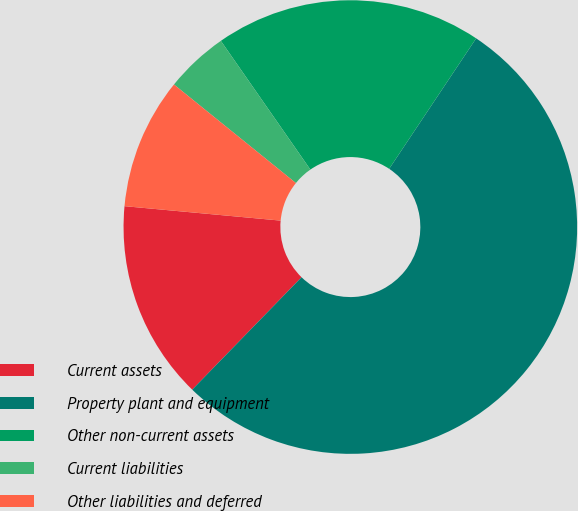<chart> <loc_0><loc_0><loc_500><loc_500><pie_chart><fcel>Current assets<fcel>Property plant and equipment<fcel>Other non-current assets<fcel>Current liabilities<fcel>Other liabilities and deferred<nl><fcel>14.19%<fcel>52.92%<fcel>19.03%<fcel>4.51%<fcel>9.35%<nl></chart> 